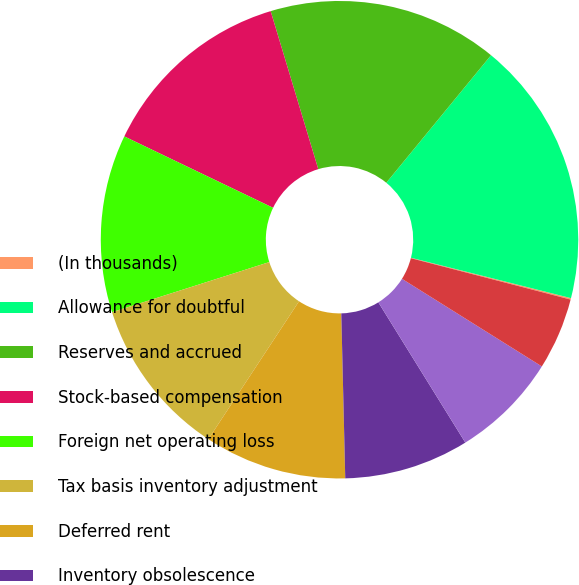Convert chart. <chart><loc_0><loc_0><loc_500><loc_500><pie_chart><fcel>(In thousands)<fcel>Allowance for doubtful<fcel>Reserves and accrued<fcel>Stock-based compensation<fcel>Foreign net operating loss<fcel>Tax basis inventory adjustment<fcel>Deferred rent<fcel>Inventory obsolescence<fcel>Foreign tax credit<fcel>State tax credits net of<nl><fcel>0.1%<fcel>17.99%<fcel>15.6%<fcel>13.22%<fcel>12.03%<fcel>10.83%<fcel>9.64%<fcel>8.45%<fcel>7.26%<fcel>4.87%<nl></chart> 